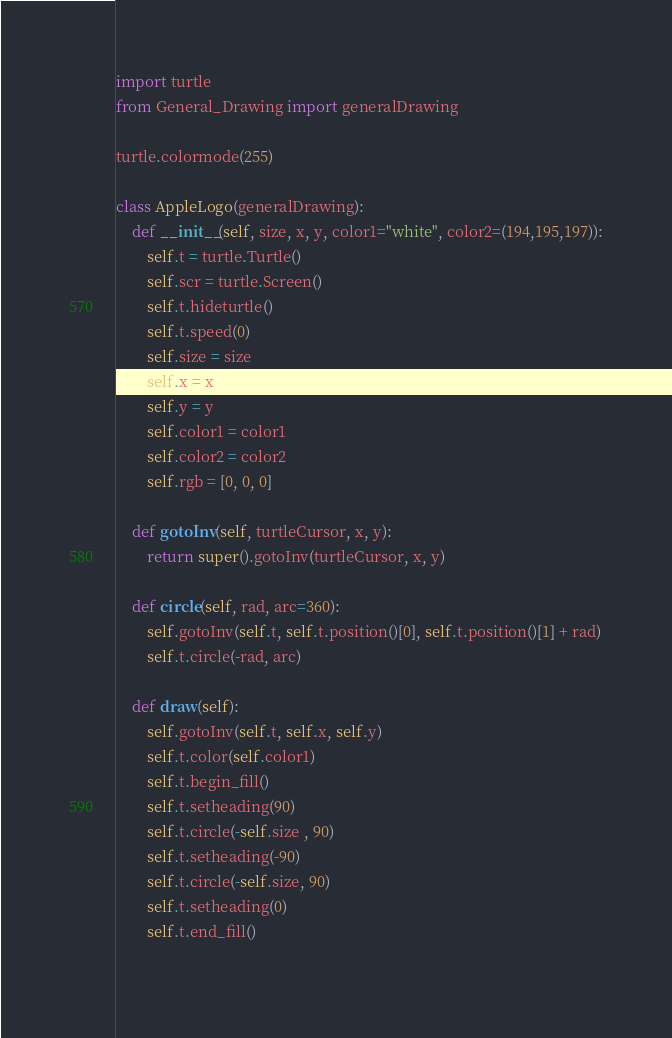Convert code to text. <code><loc_0><loc_0><loc_500><loc_500><_Python_>import turtle
from General_Drawing import generalDrawing

turtle.colormode(255)

class AppleLogo(generalDrawing):
    def __init__(self, size, x, y, color1="white", color2=(194,195,197)):
        self.t = turtle.Turtle()
        self.scr = turtle.Screen()
        self.t.hideturtle()
        self.t.speed(0)
        self.size = size
        self.x = x
        self.y = y
        self.color1 = color1
        self.color2 = color2
        self.rgb = [0, 0, 0]

    def gotoInv(self, turtleCursor, x, y):
        return super().gotoInv(turtleCursor, x, y)

    def circle(self, rad, arc=360):
        self.gotoInv(self.t, self.t.position()[0], self.t.position()[1] + rad)
        self.t.circle(-rad, arc)

    def draw(self):
        self.gotoInv(self.t, self.x, self.y)
        self.t.color(self.color1)
        self.t.begin_fill()
        self.t.setheading(90)
        self.t.circle(-self.size , 90)
        self.t.setheading(-90)
        self.t.circle(-self.size, 90)
        self.t.setheading(0)
        self.t.end_fill()
        </code> 